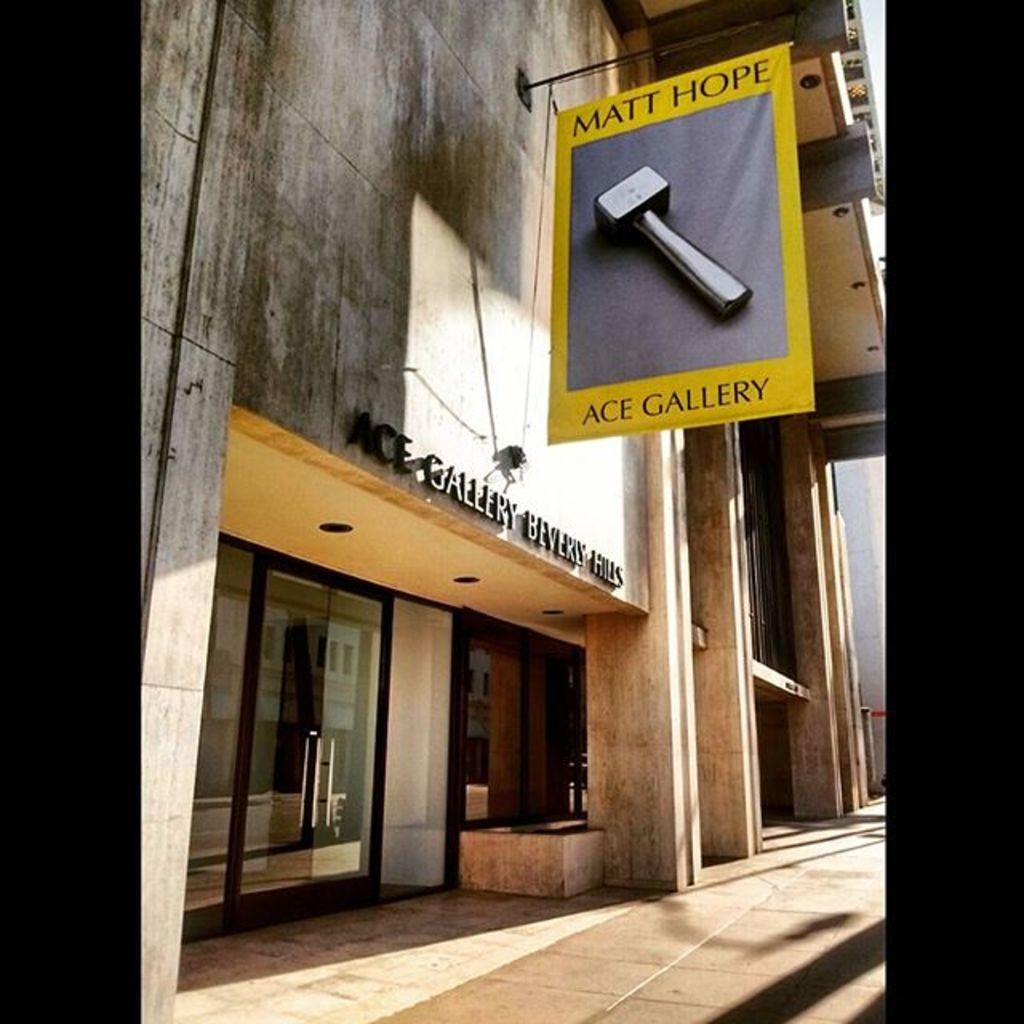What type of structure can be seen in the image? There is a building in the image. What architectural feature is present in the image? There is a wall in the image. Is there an entrance visible in the image? Yes, there is a door in the image. What additional element is present in the image? There is a banner in the image. What surface is the building standing on? There is a floor in the image. Are there any other structural elements visible in the image? Yes, there is a pillar in the image. What is the board used for in the image? The purpose of the board in the image is not specified, but it could be used for displaying information or as a surface for writing. How many nails can be seen holding the banner in the image? There is no information about nails in the image, as the banner's method of attachment is not specified. 